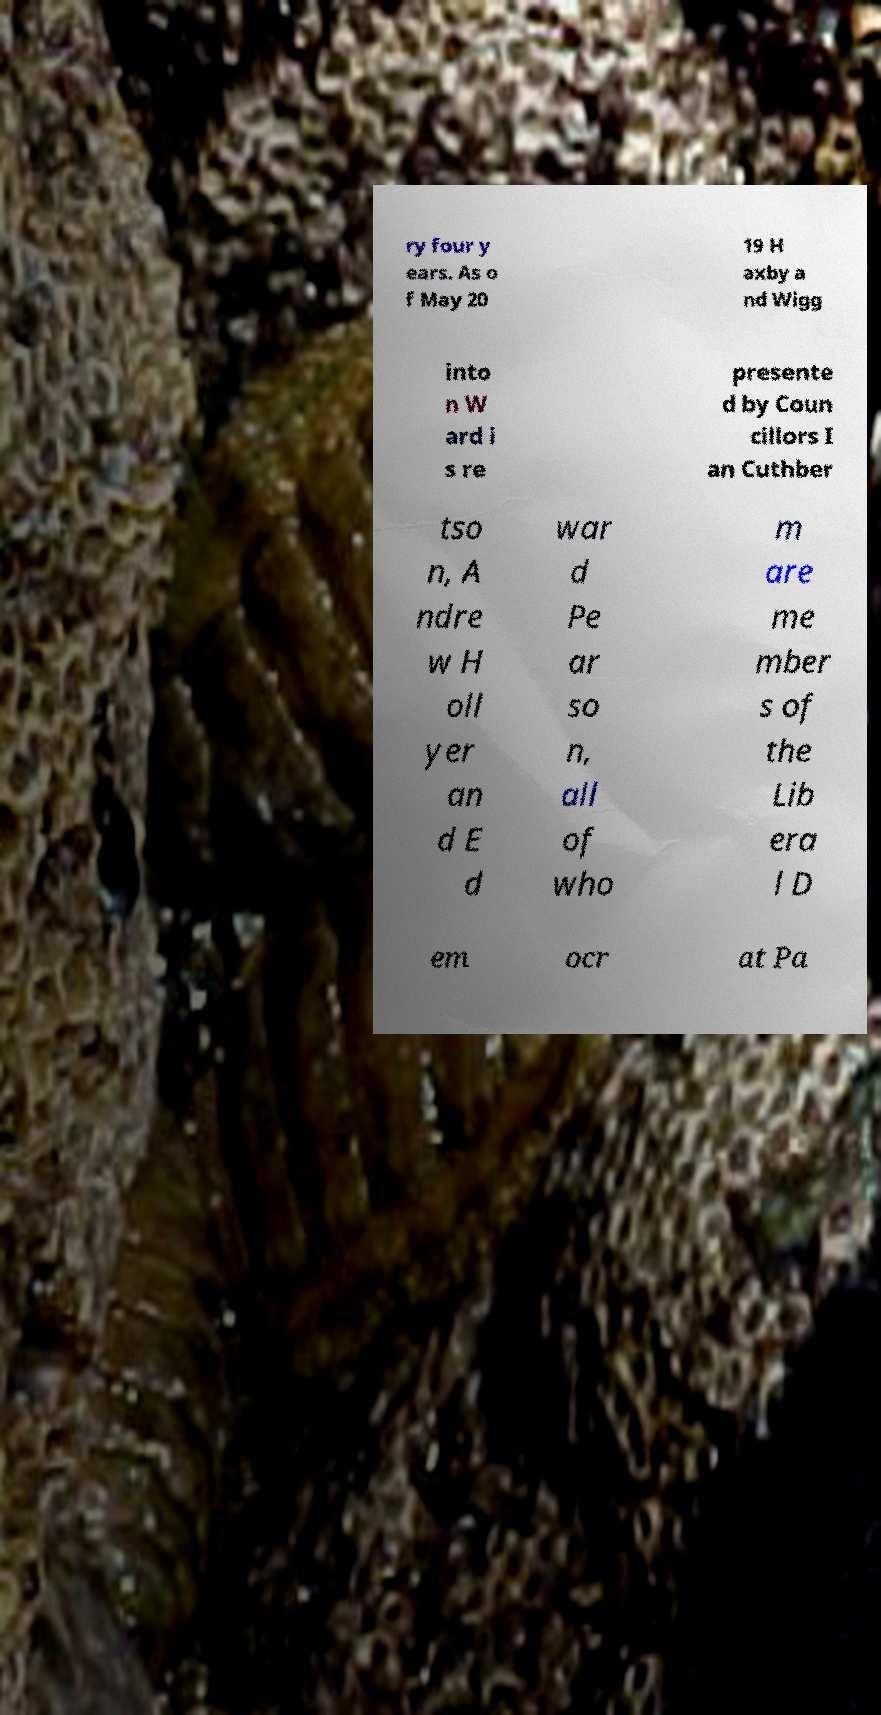Could you extract and type out the text from this image? ry four y ears. As o f May 20 19 H axby a nd Wigg into n W ard i s re presente d by Coun cillors I an Cuthber tso n, A ndre w H oll yer an d E d war d Pe ar so n, all of who m are me mber s of the Lib era l D em ocr at Pa 